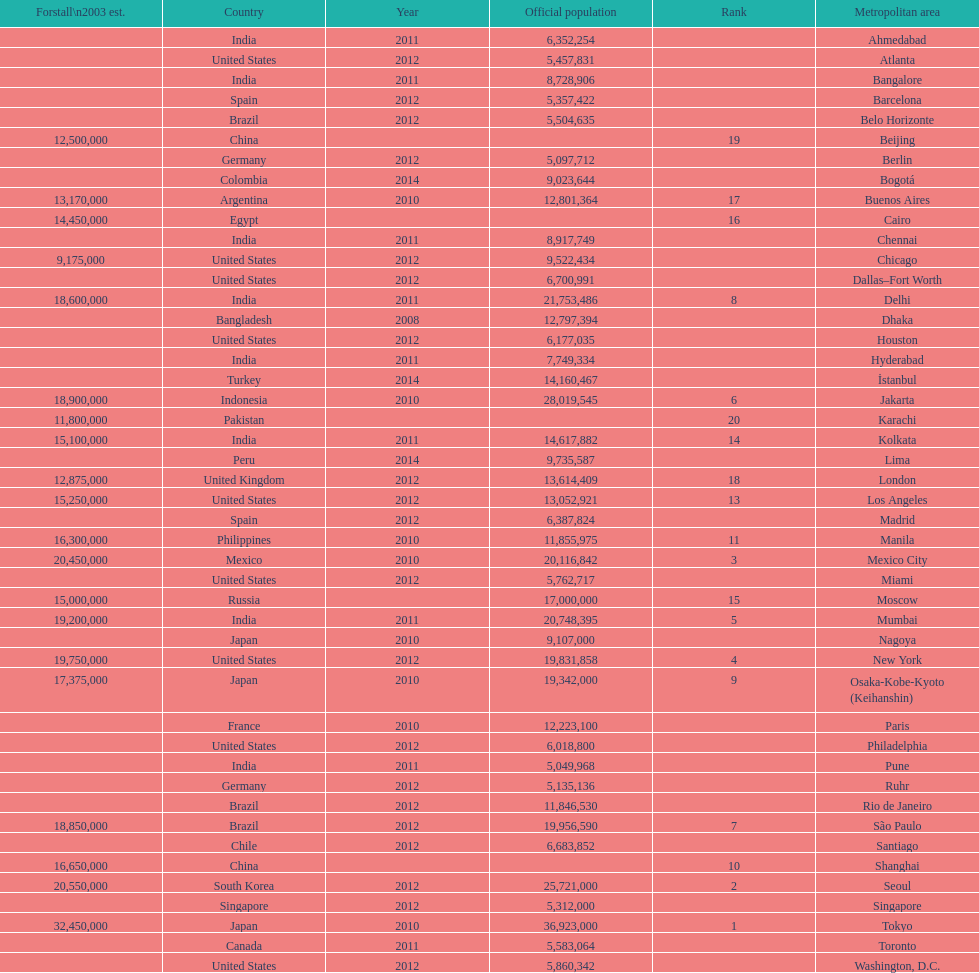Which population is listed before 5,357,422? 8,728,906. 